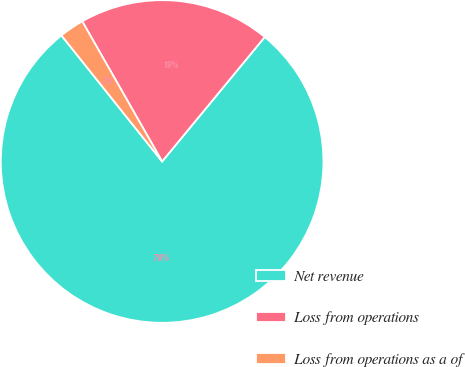<chart> <loc_0><loc_0><loc_500><loc_500><pie_chart><fcel>Net revenue<fcel>Loss from operations<fcel>Loss from operations as a of<nl><fcel>78.3%<fcel>19.22%<fcel>2.48%<nl></chart> 